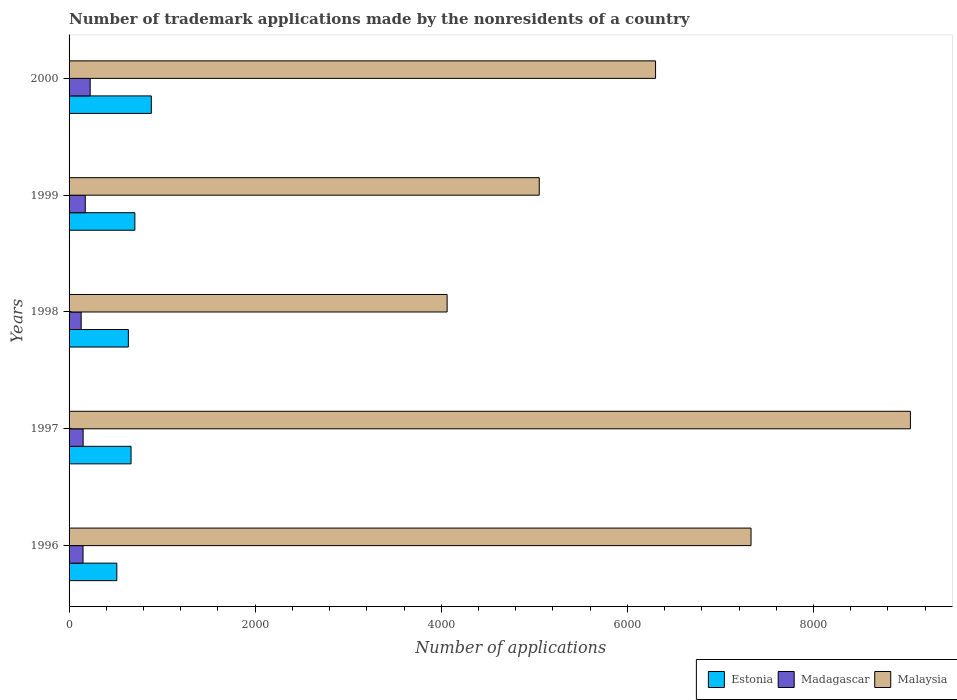How many different coloured bars are there?
Offer a very short reply. 3. How many bars are there on the 5th tick from the bottom?
Provide a succinct answer. 3. What is the label of the 1st group of bars from the top?
Provide a succinct answer. 2000. In how many cases, is the number of bars for a given year not equal to the number of legend labels?
Provide a succinct answer. 0. What is the number of trademark applications made by the nonresidents in Madagascar in 1999?
Ensure brevity in your answer.  174. Across all years, what is the maximum number of trademark applications made by the nonresidents in Madagascar?
Your answer should be compact. 227. Across all years, what is the minimum number of trademark applications made by the nonresidents in Malaysia?
Provide a succinct answer. 4063. What is the total number of trademark applications made by the nonresidents in Madagascar in the graph?
Provide a short and direct response. 832. What is the difference between the number of trademark applications made by the nonresidents in Malaysia in 2000 and the number of trademark applications made by the nonresidents in Estonia in 1999?
Offer a very short reply. 5596. What is the average number of trademark applications made by the nonresidents in Estonia per year?
Your response must be concise. 681.4. In the year 2000, what is the difference between the number of trademark applications made by the nonresidents in Estonia and number of trademark applications made by the nonresidents in Malaysia?
Ensure brevity in your answer.  -5419. In how many years, is the number of trademark applications made by the nonresidents in Estonia greater than 4400 ?
Ensure brevity in your answer.  0. What is the ratio of the number of trademark applications made by the nonresidents in Estonia in 1999 to that in 2000?
Make the answer very short. 0.8. Is the number of trademark applications made by the nonresidents in Madagascar in 1996 less than that in 1997?
Make the answer very short. Yes. What is the difference between the highest and the second highest number of trademark applications made by the nonresidents in Malaysia?
Your response must be concise. 1713. What is the difference between the highest and the lowest number of trademark applications made by the nonresidents in Estonia?
Give a very brief answer. 371. In how many years, is the number of trademark applications made by the nonresidents in Estonia greater than the average number of trademark applications made by the nonresidents in Estonia taken over all years?
Keep it short and to the point. 2. Is the sum of the number of trademark applications made by the nonresidents in Malaysia in 1997 and 1998 greater than the maximum number of trademark applications made by the nonresidents in Estonia across all years?
Your answer should be compact. Yes. What does the 1st bar from the top in 1999 represents?
Ensure brevity in your answer.  Malaysia. What does the 1st bar from the bottom in 1996 represents?
Your answer should be very brief. Estonia. How many bars are there?
Provide a succinct answer. 15. Are all the bars in the graph horizontal?
Your response must be concise. Yes. What is the difference between two consecutive major ticks on the X-axis?
Make the answer very short. 2000. Does the graph contain any zero values?
Your response must be concise. No. Does the graph contain grids?
Keep it short and to the point. No. Where does the legend appear in the graph?
Give a very brief answer. Bottom right. How many legend labels are there?
Provide a short and direct response. 3. How are the legend labels stacked?
Give a very brief answer. Horizontal. What is the title of the graph?
Keep it short and to the point. Number of trademark applications made by the nonresidents of a country. What is the label or title of the X-axis?
Your answer should be very brief. Number of applications. What is the Number of applications in Estonia in 1996?
Provide a succinct answer. 513. What is the Number of applications of Madagascar in 1996?
Keep it short and to the point. 150. What is the Number of applications in Malaysia in 1996?
Ensure brevity in your answer.  7329. What is the Number of applications in Estonia in 1997?
Provide a short and direct response. 666. What is the Number of applications of Madagascar in 1997?
Ensure brevity in your answer.  151. What is the Number of applications of Malaysia in 1997?
Make the answer very short. 9042. What is the Number of applications of Estonia in 1998?
Keep it short and to the point. 637. What is the Number of applications of Madagascar in 1998?
Your answer should be compact. 130. What is the Number of applications in Malaysia in 1998?
Provide a short and direct response. 4063. What is the Number of applications of Estonia in 1999?
Provide a succinct answer. 707. What is the Number of applications of Madagascar in 1999?
Provide a succinct answer. 174. What is the Number of applications of Malaysia in 1999?
Provide a succinct answer. 5053. What is the Number of applications of Estonia in 2000?
Provide a short and direct response. 884. What is the Number of applications in Madagascar in 2000?
Your answer should be compact. 227. What is the Number of applications of Malaysia in 2000?
Ensure brevity in your answer.  6303. Across all years, what is the maximum Number of applications in Estonia?
Ensure brevity in your answer.  884. Across all years, what is the maximum Number of applications in Madagascar?
Give a very brief answer. 227. Across all years, what is the maximum Number of applications in Malaysia?
Keep it short and to the point. 9042. Across all years, what is the minimum Number of applications of Estonia?
Provide a succinct answer. 513. Across all years, what is the minimum Number of applications in Madagascar?
Make the answer very short. 130. Across all years, what is the minimum Number of applications in Malaysia?
Your answer should be compact. 4063. What is the total Number of applications in Estonia in the graph?
Ensure brevity in your answer.  3407. What is the total Number of applications of Madagascar in the graph?
Keep it short and to the point. 832. What is the total Number of applications of Malaysia in the graph?
Keep it short and to the point. 3.18e+04. What is the difference between the Number of applications in Estonia in 1996 and that in 1997?
Offer a very short reply. -153. What is the difference between the Number of applications of Malaysia in 1996 and that in 1997?
Your response must be concise. -1713. What is the difference between the Number of applications of Estonia in 1996 and that in 1998?
Your response must be concise. -124. What is the difference between the Number of applications of Madagascar in 1996 and that in 1998?
Your answer should be compact. 20. What is the difference between the Number of applications of Malaysia in 1996 and that in 1998?
Your answer should be very brief. 3266. What is the difference between the Number of applications of Estonia in 1996 and that in 1999?
Give a very brief answer. -194. What is the difference between the Number of applications of Malaysia in 1996 and that in 1999?
Make the answer very short. 2276. What is the difference between the Number of applications in Estonia in 1996 and that in 2000?
Ensure brevity in your answer.  -371. What is the difference between the Number of applications in Madagascar in 1996 and that in 2000?
Make the answer very short. -77. What is the difference between the Number of applications of Malaysia in 1996 and that in 2000?
Offer a very short reply. 1026. What is the difference between the Number of applications in Malaysia in 1997 and that in 1998?
Your response must be concise. 4979. What is the difference between the Number of applications of Estonia in 1997 and that in 1999?
Provide a short and direct response. -41. What is the difference between the Number of applications in Madagascar in 1997 and that in 1999?
Offer a very short reply. -23. What is the difference between the Number of applications in Malaysia in 1997 and that in 1999?
Provide a short and direct response. 3989. What is the difference between the Number of applications in Estonia in 1997 and that in 2000?
Your answer should be compact. -218. What is the difference between the Number of applications in Madagascar in 1997 and that in 2000?
Provide a succinct answer. -76. What is the difference between the Number of applications of Malaysia in 1997 and that in 2000?
Your answer should be very brief. 2739. What is the difference between the Number of applications in Estonia in 1998 and that in 1999?
Offer a terse response. -70. What is the difference between the Number of applications in Madagascar in 1998 and that in 1999?
Provide a short and direct response. -44. What is the difference between the Number of applications in Malaysia in 1998 and that in 1999?
Give a very brief answer. -990. What is the difference between the Number of applications of Estonia in 1998 and that in 2000?
Provide a short and direct response. -247. What is the difference between the Number of applications in Madagascar in 1998 and that in 2000?
Ensure brevity in your answer.  -97. What is the difference between the Number of applications in Malaysia in 1998 and that in 2000?
Ensure brevity in your answer.  -2240. What is the difference between the Number of applications of Estonia in 1999 and that in 2000?
Your answer should be compact. -177. What is the difference between the Number of applications in Madagascar in 1999 and that in 2000?
Your answer should be very brief. -53. What is the difference between the Number of applications of Malaysia in 1999 and that in 2000?
Your response must be concise. -1250. What is the difference between the Number of applications of Estonia in 1996 and the Number of applications of Madagascar in 1997?
Your answer should be compact. 362. What is the difference between the Number of applications of Estonia in 1996 and the Number of applications of Malaysia in 1997?
Offer a very short reply. -8529. What is the difference between the Number of applications of Madagascar in 1996 and the Number of applications of Malaysia in 1997?
Offer a terse response. -8892. What is the difference between the Number of applications in Estonia in 1996 and the Number of applications in Madagascar in 1998?
Ensure brevity in your answer.  383. What is the difference between the Number of applications in Estonia in 1996 and the Number of applications in Malaysia in 1998?
Offer a very short reply. -3550. What is the difference between the Number of applications in Madagascar in 1996 and the Number of applications in Malaysia in 1998?
Your response must be concise. -3913. What is the difference between the Number of applications in Estonia in 1996 and the Number of applications in Madagascar in 1999?
Your answer should be compact. 339. What is the difference between the Number of applications of Estonia in 1996 and the Number of applications of Malaysia in 1999?
Provide a short and direct response. -4540. What is the difference between the Number of applications of Madagascar in 1996 and the Number of applications of Malaysia in 1999?
Keep it short and to the point. -4903. What is the difference between the Number of applications of Estonia in 1996 and the Number of applications of Madagascar in 2000?
Provide a short and direct response. 286. What is the difference between the Number of applications in Estonia in 1996 and the Number of applications in Malaysia in 2000?
Keep it short and to the point. -5790. What is the difference between the Number of applications in Madagascar in 1996 and the Number of applications in Malaysia in 2000?
Your response must be concise. -6153. What is the difference between the Number of applications in Estonia in 1997 and the Number of applications in Madagascar in 1998?
Provide a succinct answer. 536. What is the difference between the Number of applications of Estonia in 1997 and the Number of applications of Malaysia in 1998?
Your answer should be very brief. -3397. What is the difference between the Number of applications of Madagascar in 1997 and the Number of applications of Malaysia in 1998?
Your answer should be very brief. -3912. What is the difference between the Number of applications of Estonia in 1997 and the Number of applications of Madagascar in 1999?
Make the answer very short. 492. What is the difference between the Number of applications of Estonia in 1997 and the Number of applications of Malaysia in 1999?
Offer a very short reply. -4387. What is the difference between the Number of applications in Madagascar in 1997 and the Number of applications in Malaysia in 1999?
Provide a short and direct response. -4902. What is the difference between the Number of applications in Estonia in 1997 and the Number of applications in Madagascar in 2000?
Your answer should be compact. 439. What is the difference between the Number of applications in Estonia in 1997 and the Number of applications in Malaysia in 2000?
Provide a short and direct response. -5637. What is the difference between the Number of applications in Madagascar in 1997 and the Number of applications in Malaysia in 2000?
Provide a short and direct response. -6152. What is the difference between the Number of applications of Estonia in 1998 and the Number of applications of Madagascar in 1999?
Offer a very short reply. 463. What is the difference between the Number of applications in Estonia in 1998 and the Number of applications in Malaysia in 1999?
Your response must be concise. -4416. What is the difference between the Number of applications in Madagascar in 1998 and the Number of applications in Malaysia in 1999?
Provide a short and direct response. -4923. What is the difference between the Number of applications of Estonia in 1998 and the Number of applications of Madagascar in 2000?
Your answer should be very brief. 410. What is the difference between the Number of applications of Estonia in 1998 and the Number of applications of Malaysia in 2000?
Provide a succinct answer. -5666. What is the difference between the Number of applications of Madagascar in 1998 and the Number of applications of Malaysia in 2000?
Offer a very short reply. -6173. What is the difference between the Number of applications of Estonia in 1999 and the Number of applications of Madagascar in 2000?
Provide a short and direct response. 480. What is the difference between the Number of applications in Estonia in 1999 and the Number of applications in Malaysia in 2000?
Provide a short and direct response. -5596. What is the difference between the Number of applications in Madagascar in 1999 and the Number of applications in Malaysia in 2000?
Provide a succinct answer. -6129. What is the average Number of applications in Estonia per year?
Keep it short and to the point. 681.4. What is the average Number of applications in Madagascar per year?
Ensure brevity in your answer.  166.4. What is the average Number of applications of Malaysia per year?
Your answer should be very brief. 6358. In the year 1996, what is the difference between the Number of applications of Estonia and Number of applications of Madagascar?
Ensure brevity in your answer.  363. In the year 1996, what is the difference between the Number of applications of Estonia and Number of applications of Malaysia?
Provide a short and direct response. -6816. In the year 1996, what is the difference between the Number of applications of Madagascar and Number of applications of Malaysia?
Make the answer very short. -7179. In the year 1997, what is the difference between the Number of applications of Estonia and Number of applications of Madagascar?
Provide a succinct answer. 515. In the year 1997, what is the difference between the Number of applications of Estonia and Number of applications of Malaysia?
Give a very brief answer. -8376. In the year 1997, what is the difference between the Number of applications in Madagascar and Number of applications in Malaysia?
Provide a succinct answer. -8891. In the year 1998, what is the difference between the Number of applications in Estonia and Number of applications in Madagascar?
Your response must be concise. 507. In the year 1998, what is the difference between the Number of applications of Estonia and Number of applications of Malaysia?
Keep it short and to the point. -3426. In the year 1998, what is the difference between the Number of applications in Madagascar and Number of applications in Malaysia?
Provide a short and direct response. -3933. In the year 1999, what is the difference between the Number of applications in Estonia and Number of applications in Madagascar?
Your response must be concise. 533. In the year 1999, what is the difference between the Number of applications in Estonia and Number of applications in Malaysia?
Provide a short and direct response. -4346. In the year 1999, what is the difference between the Number of applications in Madagascar and Number of applications in Malaysia?
Your answer should be compact. -4879. In the year 2000, what is the difference between the Number of applications of Estonia and Number of applications of Madagascar?
Your answer should be very brief. 657. In the year 2000, what is the difference between the Number of applications of Estonia and Number of applications of Malaysia?
Your answer should be compact. -5419. In the year 2000, what is the difference between the Number of applications in Madagascar and Number of applications in Malaysia?
Make the answer very short. -6076. What is the ratio of the Number of applications in Estonia in 1996 to that in 1997?
Provide a short and direct response. 0.77. What is the ratio of the Number of applications in Malaysia in 1996 to that in 1997?
Ensure brevity in your answer.  0.81. What is the ratio of the Number of applications of Estonia in 1996 to that in 1998?
Give a very brief answer. 0.81. What is the ratio of the Number of applications in Madagascar in 1996 to that in 1998?
Give a very brief answer. 1.15. What is the ratio of the Number of applications of Malaysia in 1996 to that in 1998?
Provide a succinct answer. 1.8. What is the ratio of the Number of applications in Estonia in 1996 to that in 1999?
Provide a succinct answer. 0.73. What is the ratio of the Number of applications of Madagascar in 1996 to that in 1999?
Give a very brief answer. 0.86. What is the ratio of the Number of applications in Malaysia in 1996 to that in 1999?
Ensure brevity in your answer.  1.45. What is the ratio of the Number of applications in Estonia in 1996 to that in 2000?
Your answer should be very brief. 0.58. What is the ratio of the Number of applications in Madagascar in 1996 to that in 2000?
Your response must be concise. 0.66. What is the ratio of the Number of applications in Malaysia in 1996 to that in 2000?
Offer a very short reply. 1.16. What is the ratio of the Number of applications of Estonia in 1997 to that in 1998?
Your answer should be very brief. 1.05. What is the ratio of the Number of applications of Madagascar in 1997 to that in 1998?
Make the answer very short. 1.16. What is the ratio of the Number of applications of Malaysia in 1997 to that in 1998?
Provide a succinct answer. 2.23. What is the ratio of the Number of applications of Estonia in 1997 to that in 1999?
Your answer should be compact. 0.94. What is the ratio of the Number of applications of Madagascar in 1997 to that in 1999?
Ensure brevity in your answer.  0.87. What is the ratio of the Number of applications in Malaysia in 1997 to that in 1999?
Give a very brief answer. 1.79. What is the ratio of the Number of applications of Estonia in 1997 to that in 2000?
Offer a very short reply. 0.75. What is the ratio of the Number of applications of Madagascar in 1997 to that in 2000?
Provide a succinct answer. 0.67. What is the ratio of the Number of applications of Malaysia in 1997 to that in 2000?
Provide a short and direct response. 1.43. What is the ratio of the Number of applications of Estonia in 1998 to that in 1999?
Provide a short and direct response. 0.9. What is the ratio of the Number of applications in Madagascar in 1998 to that in 1999?
Make the answer very short. 0.75. What is the ratio of the Number of applications of Malaysia in 1998 to that in 1999?
Make the answer very short. 0.8. What is the ratio of the Number of applications of Estonia in 1998 to that in 2000?
Keep it short and to the point. 0.72. What is the ratio of the Number of applications in Madagascar in 1998 to that in 2000?
Give a very brief answer. 0.57. What is the ratio of the Number of applications in Malaysia in 1998 to that in 2000?
Ensure brevity in your answer.  0.64. What is the ratio of the Number of applications in Estonia in 1999 to that in 2000?
Offer a terse response. 0.8. What is the ratio of the Number of applications in Madagascar in 1999 to that in 2000?
Provide a succinct answer. 0.77. What is the ratio of the Number of applications in Malaysia in 1999 to that in 2000?
Provide a short and direct response. 0.8. What is the difference between the highest and the second highest Number of applications in Estonia?
Keep it short and to the point. 177. What is the difference between the highest and the second highest Number of applications of Madagascar?
Ensure brevity in your answer.  53. What is the difference between the highest and the second highest Number of applications of Malaysia?
Provide a succinct answer. 1713. What is the difference between the highest and the lowest Number of applications in Estonia?
Keep it short and to the point. 371. What is the difference between the highest and the lowest Number of applications in Madagascar?
Make the answer very short. 97. What is the difference between the highest and the lowest Number of applications in Malaysia?
Provide a succinct answer. 4979. 